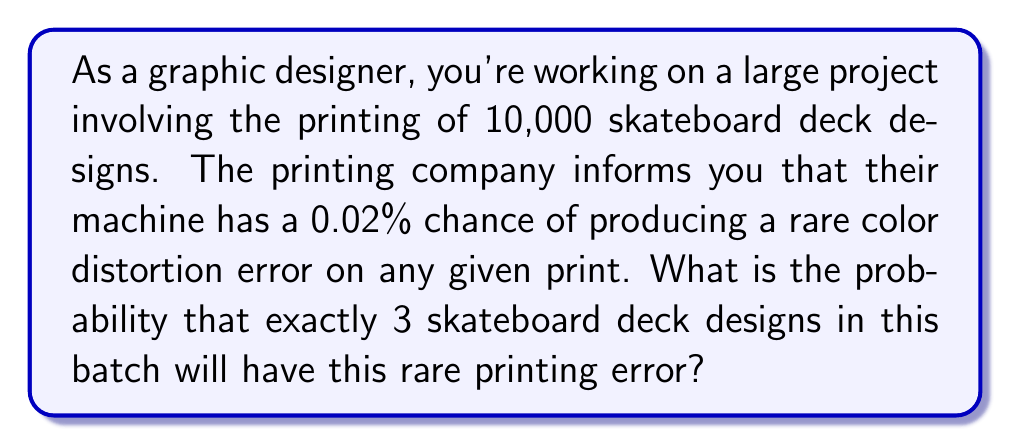Can you solve this math problem? To solve this problem, we'll use the Binomial probability distribution, as we're dealing with a fixed number of independent trials (prints) with two possible outcomes (error or no error) and a constant probability of success (error occurring).

Let's define our variables:
$n = 10000$ (number of prints)
$p = 0.0002$ (probability of error, 0.02% expressed as a decimal)
$k = 3$ (number of errors we're interested in)

The probability mass function for the Binomial distribution is:

$$ P(X = k) = \binom{n}{k} p^k (1-p)^{n-k} $$

Where $\binom{n}{k}$ is the binomial coefficient, calculated as:

$$ \binom{n}{k} = \frac{n!}{k!(n-k)!} $$

Let's calculate step by step:

1) Calculate the binomial coefficient:
   $\binom{10000}{3} = \frac{10000!}{3!(10000-3)!} = 166616670000$

2) Calculate $p^k$:
   $0.0002^3 = 8 \times 10^{-12}$

3) Calculate $(1-p)^{n-k}$:
   $0.9998^{9997} \approx 0.1353$

4) Multiply all parts together:
   $166616670000 \times 8 \times 10^{-12} \times 0.1353 \approx 0.1804$

Therefore, the probability of exactly 3 skateboard deck designs having the rare printing error is approximately 0.1804 or 18.04%.
Answer: $0.1804$ or $18.04\%$ 